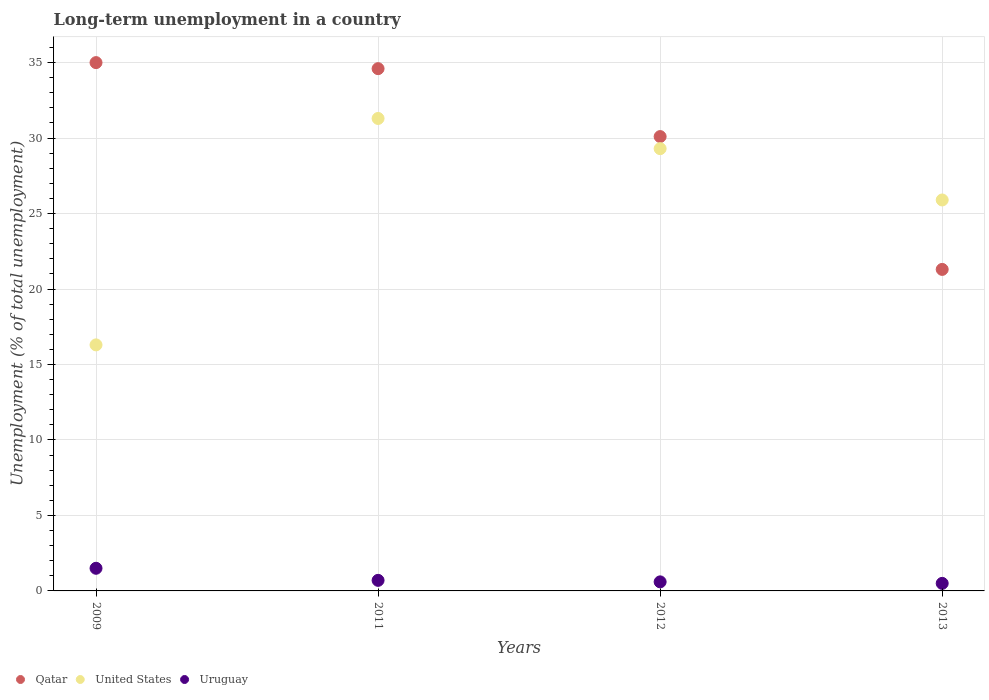How many different coloured dotlines are there?
Give a very brief answer. 3. Is the number of dotlines equal to the number of legend labels?
Keep it short and to the point. Yes. Across all years, what is the maximum percentage of long-term unemployed population in Uruguay?
Give a very brief answer. 1.5. Across all years, what is the minimum percentage of long-term unemployed population in United States?
Your answer should be very brief. 16.3. In which year was the percentage of long-term unemployed population in United States maximum?
Your answer should be compact. 2011. What is the total percentage of long-term unemployed population in Qatar in the graph?
Your response must be concise. 121. What is the difference between the percentage of long-term unemployed population in Uruguay in 2011 and that in 2013?
Offer a terse response. 0.2. What is the difference between the percentage of long-term unemployed population in United States in 2011 and the percentage of long-term unemployed population in Qatar in 2012?
Provide a succinct answer. 1.2. What is the average percentage of long-term unemployed population in Qatar per year?
Ensure brevity in your answer.  30.25. In the year 2011, what is the difference between the percentage of long-term unemployed population in Uruguay and percentage of long-term unemployed population in Qatar?
Provide a short and direct response. -33.9. In how many years, is the percentage of long-term unemployed population in Uruguay greater than 21 %?
Offer a terse response. 0. What is the ratio of the percentage of long-term unemployed population in United States in 2009 to that in 2011?
Your answer should be compact. 0.52. Is the difference between the percentage of long-term unemployed population in Uruguay in 2009 and 2013 greater than the difference between the percentage of long-term unemployed population in Qatar in 2009 and 2013?
Your answer should be very brief. No. What is the difference between the highest and the lowest percentage of long-term unemployed population in Qatar?
Ensure brevity in your answer.  13.7. In how many years, is the percentage of long-term unemployed population in Qatar greater than the average percentage of long-term unemployed population in Qatar taken over all years?
Ensure brevity in your answer.  2. How many years are there in the graph?
Provide a short and direct response. 4. What is the difference between two consecutive major ticks on the Y-axis?
Provide a succinct answer. 5. Are the values on the major ticks of Y-axis written in scientific E-notation?
Offer a terse response. No. Does the graph contain any zero values?
Ensure brevity in your answer.  No. Does the graph contain grids?
Provide a succinct answer. Yes. How are the legend labels stacked?
Provide a short and direct response. Horizontal. What is the title of the graph?
Your response must be concise. Long-term unemployment in a country. What is the label or title of the Y-axis?
Provide a succinct answer. Unemployment (% of total unemployment). What is the Unemployment (% of total unemployment) of United States in 2009?
Keep it short and to the point. 16.3. What is the Unemployment (% of total unemployment) in Uruguay in 2009?
Provide a succinct answer. 1.5. What is the Unemployment (% of total unemployment) of Qatar in 2011?
Offer a very short reply. 34.6. What is the Unemployment (% of total unemployment) in United States in 2011?
Ensure brevity in your answer.  31.3. What is the Unemployment (% of total unemployment) of Uruguay in 2011?
Keep it short and to the point. 0.7. What is the Unemployment (% of total unemployment) of Qatar in 2012?
Give a very brief answer. 30.1. What is the Unemployment (% of total unemployment) of United States in 2012?
Give a very brief answer. 29.3. What is the Unemployment (% of total unemployment) of Uruguay in 2012?
Make the answer very short. 0.6. What is the Unemployment (% of total unemployment) of Qatar in 2013?
Ensure brevity in your answer.  21.3. What is the Unemployment (% of total unemployment) of United States in 2013?
Your answer should be compact. 25.9. What is the Unemployment (% of total unemployment) of Uruguay in 2013?
Offer a terse response. 0.5. Across all years, what is the maximum Unemployment (% of total unemployment) in United States?
Offer a very short reply. 31.3. Across all years, what is the minimum Unemployment (% of total unemployment) of Qatar?
Keep it short and to the point. 21.3. Across all years, what is the minimum Unemployment (% of total unemployment) of United States?
Make the answer very short. 16.3. Across all years, what is the minimum Unemployment (% of total unemployment) of Uruguay?
Ensure brevity in your answer.  0.5. What is the total Unemployment (% of total unemployment) of Qatar in the graph?
Provide a short and direct response. 121. What is the total Unemployment (% of total unemployment) in United States in the graph?
Make the answer very short. 102.8. What is the difference between the Unemployment (% of total unemployment) in Qatar in 2009 and that in 2011?
Your answer should be compact. 0.4. What is the difference between the Unemployment (% of total unemployment) in United States in 2009 and that in 2011?
Your response must be concise. -15. What is the difference between the Unemployment (% of total unemployment) of Qatar in 2009 and that in 2012?
Offer a very short reply. 4.9. What is the difference between the Unemployment (% of total unemployment) of Uruguay in 2009 and that in 2012?
Provide a short and direct response. 0.9. What is the difference between the Unemployment (% of total unemployment) in Qatar in 2009 and that in 2013?
Provide a succinct answer. 13.7. What is the difference between the Unemployment (% of total unemployment) of Qatar in 2011 and that in 2013?
Your response must be concise. 13.3. What is the difference between the Unemployment (% of total unemployment) in Uruguay in 2011 and that in 2013?
Offer a terse response. 0.2. What is the difference between the Unemployment (% of total unemployment) of Qatar in 2012 and that in 2013?
Your response must be concise. 8.8. What is the difference between the Unemployment (% of total unemployment) in United States in 2012 and that in 2013?
Your answer should be very brief. 3.4. What is the difference between the Unemployment (% of total unemployment) of Uruguay in 2012 and that in 2013?
Ensure brevity in your answer.  0.1. What is the difference between the Unemployment (% of total unemployment) in Qatar in 2009 and the Unemployment (% of total unemployment) in United States in 2011?
Make the answer very short. 3.7. What is the difference between the Unemployment (% of total unemployment) of Qatar in 2009 and the Unemployment (% of total unemployment) of Uruguay in 2011?
Provide a short and direct response. 34.3. What is the difference between the Unemployment (% of total unemployment) of United States in 2009 and the Unemployment (% of total unemployment) of Uruguay in 2011?
Make the answer very short. 15.6. What is the difference between the Unemployment (% of total unemployment) of Qatar in 2009 and the Unemployment (% of total unemployment) of Uruguay in 2012?
Make the answer very short. 34.4. What is the difference between the Unemployment (% of total unemployment) in United States in 2009 and the Unemployment (% of total unemployment) in Uruguay in 2012?
Ensure brevity in your answer.  15.7. What is the difference between the Unemployment (% of total unemployment) in Qatar in 2009 and the Unemployment (% of total unemployment) in Uruguay in 2013?
Ensure brevity in your answer.  34.5. What is the difference between the Unemployment (% of total unemployment) in United States in 2009 and the Unemployment (% of total unemployment) in Uruguay in 2013?
Your response must be concise. 15.8. What is the difference between the Unemployment (% of total unemployment) of Qatar in 2011 and the Unemployment (% of total unemployment) of United States in 2012?
Make the answer very short. 5.3. What is the difference between the Unemployment (% of total unemployment) of Qatar in 2011 and the Unemployment (% of total unemployment) of Uruguay in 2012?
Provide a short and direct response. 34. What is the difference between the Unemployment (% of total unemployment) in United States in 2011 and the Unemployment (% of total unemployment) in Uruguay in 2012?
Provide a short and direct response. 30.7. What is the difference between the Unemployment (% of total unemployment) in Qatar in 2011 and the Unemployment (% of total unemployment) in Uruguay in 2013?
Offer a terse response. 34.1. What is the difference between the Unemployment (% of total unemployment) in United States in 2011 and the Unemployment (% of total unemployment) in Uruguay in 2013?
Make the answer very short. 30.8. What is the difference between the Unemployment (% of total unemployment) in Qatar in 2012 and the Unemployment (% of total unemployment) in Uruguay in 2013?
Provide a short and direct response. 29.6. What is the difference between the Unemployment (% of total unemployment) in United States in 2012 and the Unemployment (% of total unemployment) in Uruguay in 2013?
Your answer should be very brief. 28.8. What is the average Unemployment (% of total unemployment) in Qatar per year?
Your answer should be compact. 30.25. What is the average Unemployment (% of total unemployment) in United States per year?
Make the answer very short. 25.7. What is the average Unemployment (% of total unemployment) of Uruguay per year?
Offer a terse response. 0.82. In the year 2009, what is the difference between the Unemployment (% of total unemployment) in Qatar and Unemployment (% of total unemployment) in Uruguay?
Provide a short and direct response. 33.5. In the year 2009, what is the difference between the Unemployment (% of total unemployment) of United States and Unemployment (% of total unemployment) of Uruguay?
Make the answer very short. 14.8. In the year 2011, what is the difference between the Unemployment (% of total unemployment) in Qatar and Unemployment (% of total unemployment) in United States?
Offer a terse response. 3.3. In the year 2011, what is the difference between the Unemployment (% of total unemployment) of Qatar and Unemployment (% of total unemployment) of Uruguay?
Ensure brevity in your answer.  33.9. In the year 2011, what is the difference between the Unemployment (% of total unemployment) of United States and Unemployment (% of total unemployment) of Uruguay?
Provide a succinct answer. 30.6. In the year 2012, what is the difference between the Unemployment (% of total unemployment) of Qatar and Unemployment (% of total unemployment) of Uruguay?
Make the answer very short. 29.5. In the year 2012, what is the difference between the Unemployment (% of total unemployment) of United States and Unemployment (% of total unemployment) of Uruguay?
Offer a very short reply. 28.7. In the year 2013, what is the difference between the Unemployment (% of total unemployment) of Qatar and Unemployment (% of total unemployment) of Uruguay?
Give a very brief answer. 20.8. In the year 2013, what is the difference between the Unemployment (% of total unemployment) in United States and Unemployment (% of total unemployment) in Uruguay?
Ensure brevity in your answer.  25.4. What is the ratio of the Unemployment (% of total unemployment) of Qatar in 2009 to that in 2011?
Ensure brevity in your answer.  1.01. What is the ratio of the Unemployment (% of total unemployment) in United States in 2009 to that in 2011?
Give a very brief answer. 0.52. What is the ratio of the Unemployment (% of total unemployment) of Uruguay in 2009 to that in 2011?
Give a very brief answer. 2.14. What is the ratio of the Unemployment (% of total unemployment) in Qatar in 2009 to that in 2012?
Keep it short and to the point. 1.16. What is the ratio of the Unemployment (% of total unemployment) in United States in 2009 to that in 2012?
Give a very brief answer. 0.56. What is the ratio of the Unemployment (% of total unemployment) in Uruguay in 2009 to that in 2012?
Your answer should be very brief. 2.5. What is the ratio of the Unemployment (% of total unemployment) in Qatar in 2009 to that in 2013?
Offer a very short reply. 1.64. What is the ratio of the Unemployment (% of total unemployment) of United States in 2009 to that in 2013?
Provide a short and direct response. 0.63. What is the ratio of the Unemployment (% of total unemployment) in Qatar in 2011 to that in 2012?
Offer a very short reply. 1.15. What is the ratio of the Unemployment (% of total unemployment) in United States in 2011 to that in 2012?
Offer a very short reply. 1.07. What is the ratio of the Unemployment (% of total unemployment) of Qatar in 2011 to that in 2013?
Make the answer very short. 1.62. What is the ratio of the Unemployment (% of total unemployment) in United States in 2011 to that in 2013?
Give a very brief answer. 1.21. What is the ratio of the Unemployment (% of total unemployment) of Uruguay in 2011 to that in 2013?
Provide a short and direct response. 1.4. What is the ratio of the Unemployment (% of total unemployment) in Qatar in 2012 to that in 2013?
Give a very brief answer. 1.41. What is the ratio of the Unemployment (% of total unemployment) in United States in 2012 to that in 2013?
Provide a succinct answer. 1.13. What is the difference between the highest and the lowest Unemployment (% of total unemployment) of United States?
Give a very brief answer. 15. What is the difference between the highest and the lowest Unemployment (% of total unemployment) of Uruguay?
Give a very brief answer. 1. 